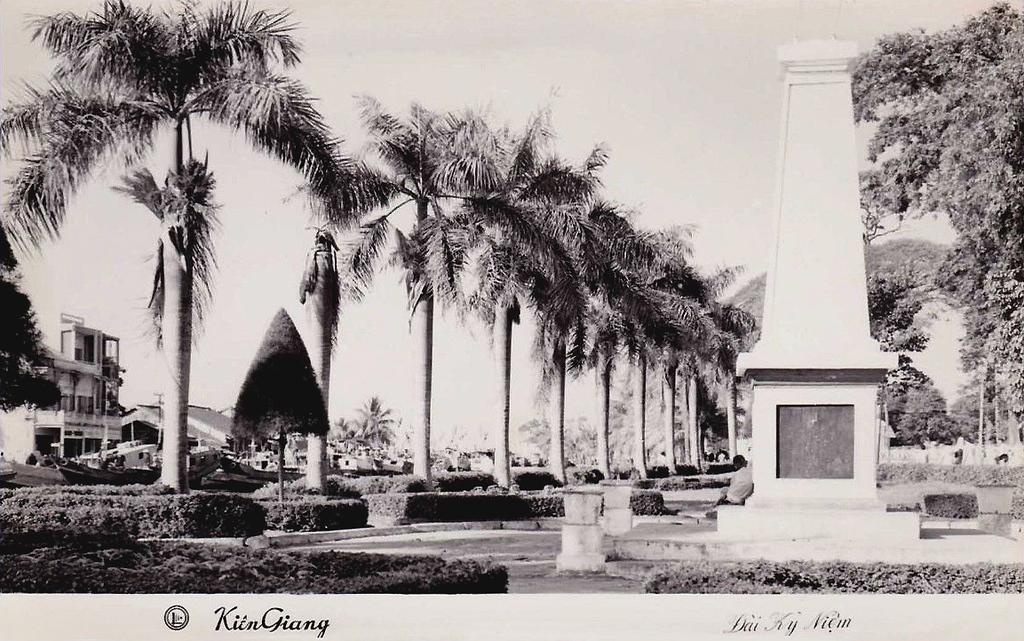In one or two sentences, can you explain what this image depicts? In this image I can see a poster. There is a memorial on the right. There are trees and buildings on the left. There is sky at the top and this is a black and white image. 